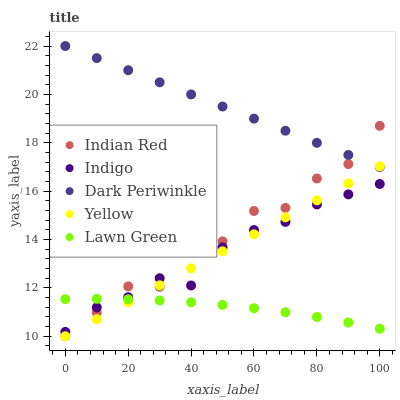Does Lawn Green have the minimum area under the curve?
Answer yes or no. Yes. Does Dark Periwinkle have the maximum area under the curve?
Answer yes or no. Yes. Does Yellow have the minimum area under the curve?
Answer yes or no. No. Does Yellow have the maximum area under the curve?
Answer yes or no. No. Is Yellow the smoothest?
Answer yes or no. Yes. Is Indian Red the roughest?
Answer yes or no. Yes. Is Indigo the smoothest?
Answer yes or no. No. Is Indigo the roughest?
Answer yes or no. No. Does Yellow have the lowest value?
Answer yes or no. Yes. Does Indigo have the lowest value?
Answer yes or no. No. Does Dark Periwinkle have the highest value?
Answer yes or no. Yes. Does Yellow have the highest value?
Answer yes or no. No. Is Lawn Green less than Dark Periwinkle?
Answer yes or no. Yes. Is Dark Periwinkle greater than Lawn Green?
Answer yes or no. Yes. Does Indigo intersect Lawn Green?
Answer yes or no. Yes. Is Indigo less than Lawn Green?
Answer yes or no. No. Is Indigo greater than Lawn Green?
Answer yes or no. No. Does Lawn Green intersect Dark Periwinkle?
Answer yes or no. No. 